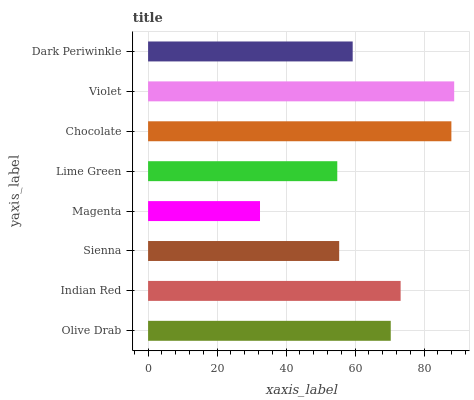Is Magenta the minimum?
Answer yes or no. Yes. Is Violet the maximum?
Answer yes or no. Yes. Is Indian Red the minimum?
Answer yes or no. No. Is Indian Red the maximum?
Answer yes or no. No. Is Indian Red greater than Olive Drab?
Answer yes or no. Yes. Is Olive Drab less than Indian Red?
Answer yes or no. Yes. Is Olive Drab greater than Indian Red?
Answer yes or no. No. Is Indian Red less than Olive Drab?
Answer yes or no. No. Is Olive Drab the high median?
Answer yes or no. Yes. Is Dark Periwinkle the low median?
Answer yes or no. Yes. Is Violet the high median?
Answer yes or no. No. Is Sienna the low median?
Answer yes or no. No. 